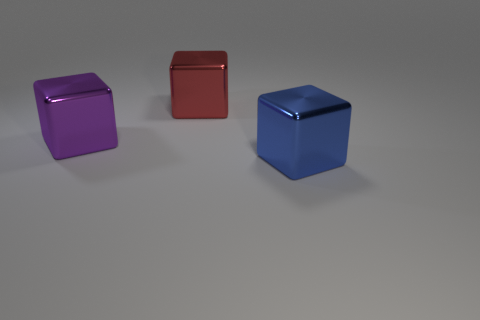Add 3 large cubes. How many objects exist? 6 Subtract all blue blocks. How many blocks are left? 2 Subtract 1 blocks. How many blocks are left? 2 Subtract all red cubes. How many cubes are left? 2 Subtract 1 red cubes. How many objects are left? 2 Subtract all blue blocks. Subtract all blue spheres. How many blocks are left? 2 Subtract all blue balls. How many red blocks are left? 1 Subtract all small cyan rubber cubes. Subtract all large purple metallic objects. How many objects are left? 2 Add 3 big purple objects. How many big purple objects are left? 4 Add 2 large blue metal blocks. How many large blue metal blocks exist? 3 